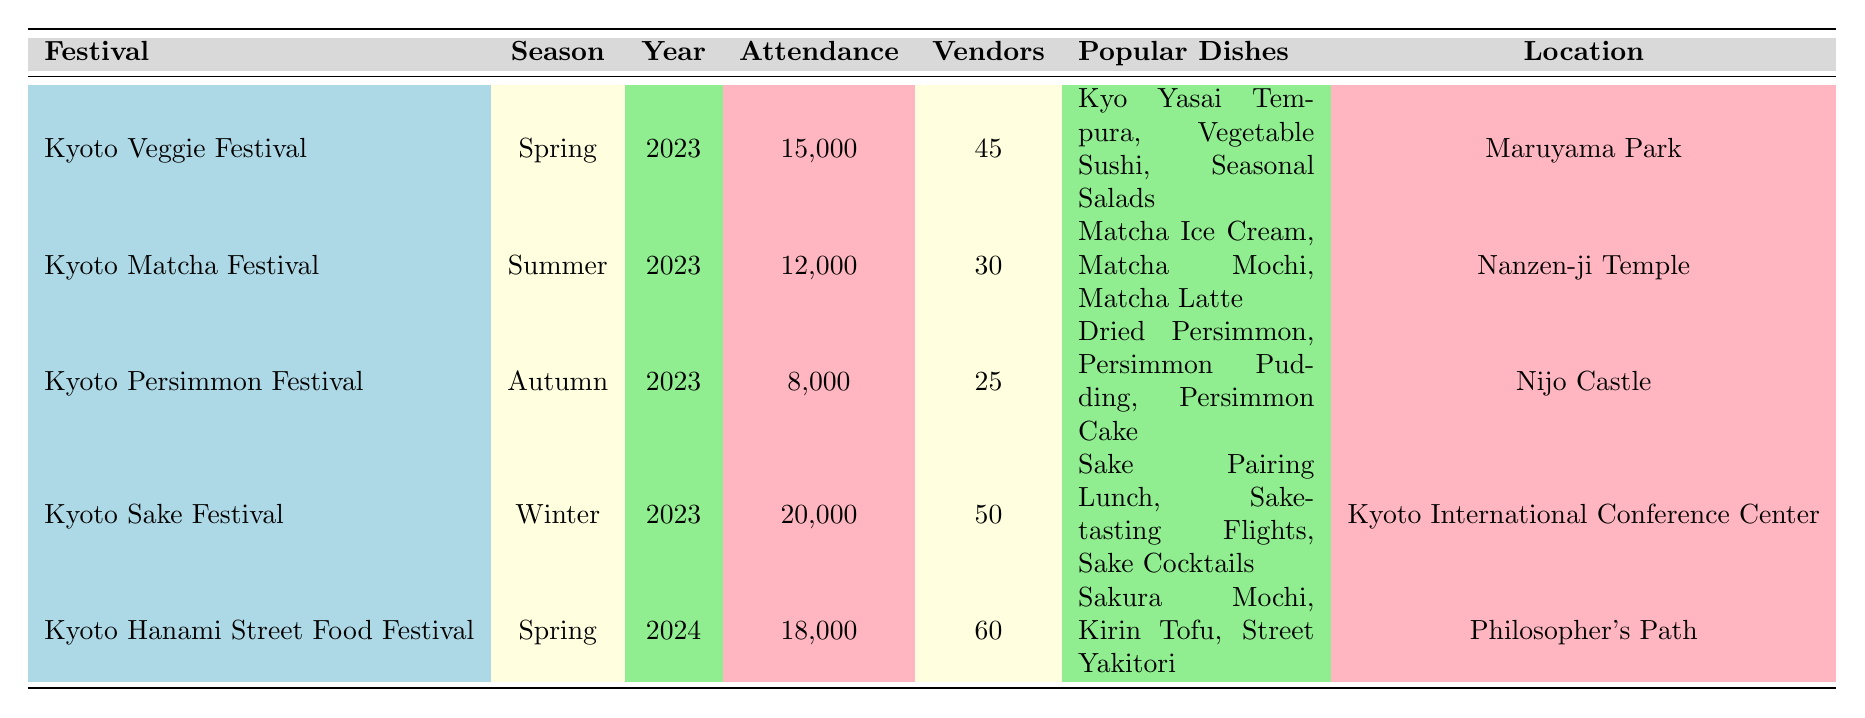What is the total attendance for the Kyoto Veggie Festival in 2023? The value for attendance under the Kyoto Veggie Festival in 2023 is 15,000.
Answer: 15,000 How many vendors participated in the Kyoto Sake Festival? The number of vendors for the Kyoto Sake Festival is 50, as listed in the table.
Answer: 50 Which festival had the highest attendance? The Kyoto Sake Festival had the highest attendance at 20,000, compared to other festivals.
Answer: Kyoto Sake Festival What are the popular dishes served at the Kyoto Matcha Festival? The popular dishes for the Kyoto Matcha Festival include Matcha Ice Cream, Matcha Mochi, and Matcha Latte, as per the table.
Answer: Matcha Ice Cream, Matcha Mochi, Matcha Latte What is the total vendor participation for all festivals in 2023? Adding the vendors: 45 (Veggie) + 30 (Matcha) + 25 (Persimmon) + 50 (Sake) = 150 vendors in total for 2023.
Answer: 150 Is the Kyoto Hanami Street Food Festival taking place in Spring? The Kyoto Hanami Street Food Festival is indeed scheduled for Spring, as indicated in the season column.
Answer: Yes What is the average attendance of festivals in Spring? The attendance for Spring festivals: 15,000 (Veggie) + 18,000 (Hanami) = 33,000. Number of Spring festivals is 2, thus the average is 33,000/2 = 16,500.
Answer: 16,500 Which season has the fewest vendors participating and what is that count? The Kyoto Persimmon Festival in Autumn has the fewest vendors participating with a count of 25.
Answer: 25 What is the difference in attendance between the Kyoto Sake Festival and the Kyoto Persimmon Festival? The Kyoto Sake Festival had an attendance of 20,000, and the Persimmon Festival had 8,000. Therefore, the difference is 20,000 - 8,000 = 12,000.
Answer: 12,000 Which festival has a larger vendor participation, the Kyoto Matcha Festival or the Kyoto Persimmon Festival? The Kyoto Matcha Festival has 30 vendors while the Kyoto Persimmon Festival has 25 vendors, making Matcha Festival the larger one.
Answer: Kyoto Matcha Festival 